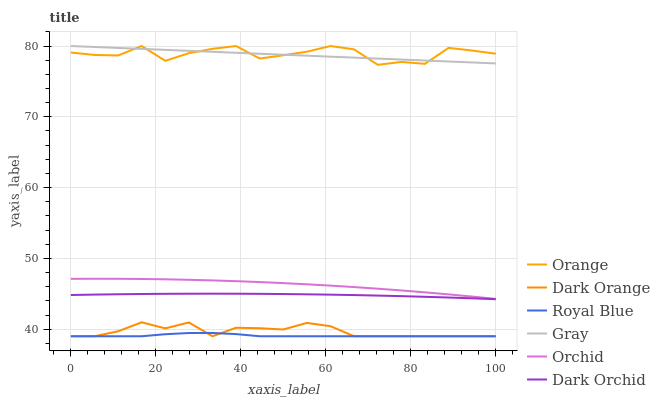Does Royal Blue have the minimum area under the curve?
Answer yes or no. Yes. Does Orange have the maximum area under the curve?
Answer yes or no. Yes. Does Gray have the minimum area under the curve?
Answer yes or no. No. Does Gray have the maximum area under the curve?
Answer yes or no. No. Is Gray the smoothest?
Answer yes or no. Yes. Is Orange the roughest?
Answer yes or no. Yes. Is Dark Orchid the smoothest?
Answer yes or no. No. Is Dark Orchid the roughest?
Answer yes or no. No. Does Dark Orange have the lowest value?
Answer yes or no. Yes. Does Dark Orchid have the lowest value?
Answer yes or no. No. Does Orange have the highest value?
Answer yes or no. Yes. Does Dark Orchid have the highest value?
Answer yes or no. No. Is Orchid less than Orange?
Answer yes or no. Yes. Is Orchid greater than Dark Orange?
Answer yes or no. Yes. Does Dark Orange intersect Royal Blue?
Answer yes or no. Yes. Is Dark Orange less than Royal Blue?
Answer yes or no. No. Is Dark Orange greater than Royal Blue?
Answer yes or no. No. Does Orchid intersect Orange?
Answer yes or no. No. 